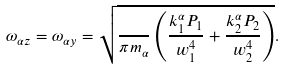Convert formula to latex. <formula><loc_0><loc_0><loc_500><loc_500>\omega _ { \alpha z } = \omega _ { \alpha y } = \sqrt { \frac { } { \pi m _ { \alpha } } \left ( \frac { k ^ { \alpha } _ { 1 } P _ { 1 } } { w _ { 1 } ^ { 4 } } + \frac { k ^ { \alpha } _ { 2 } P _ { 2 } } { w _ { 2 } ^ { 4 } } \right ) } .</formula> 